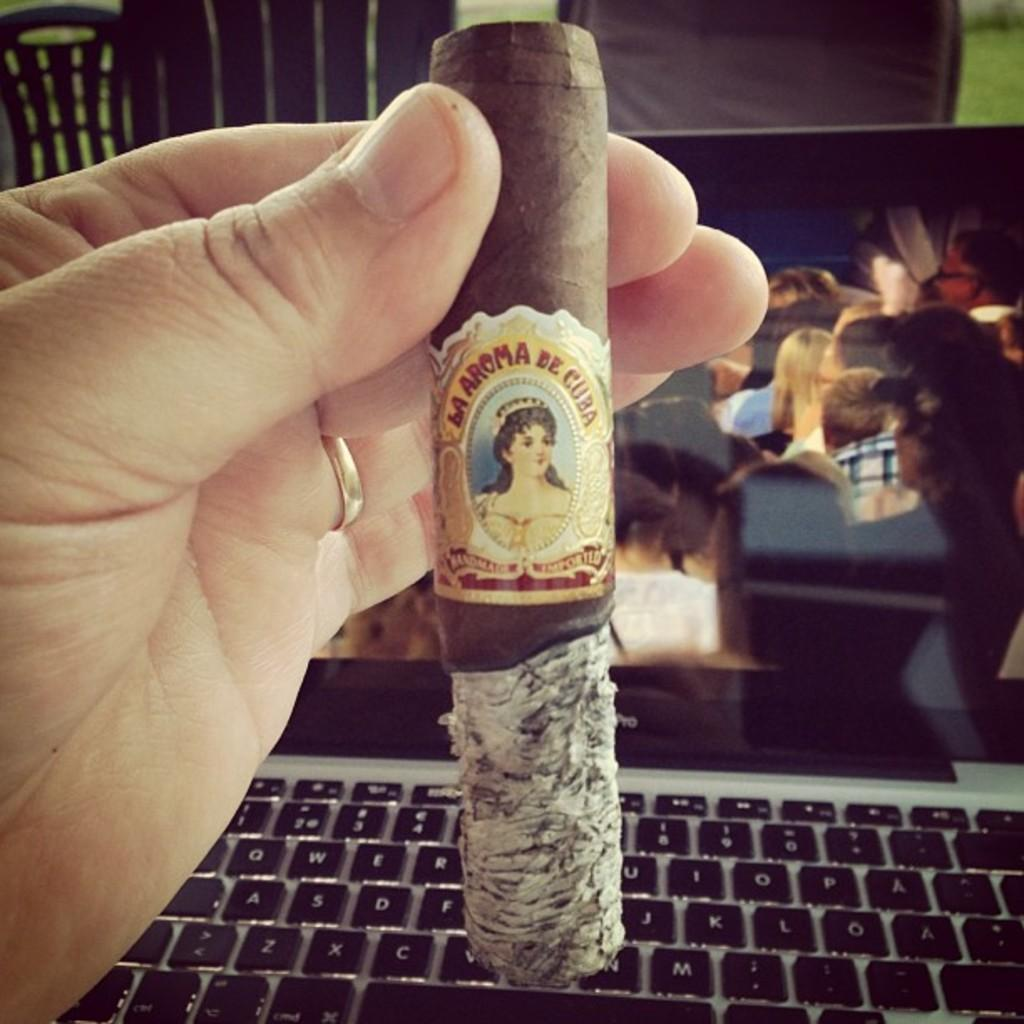Provide a one-sentence caption for the provided image. A person holding up a cigar that says la aroma de cuba. 